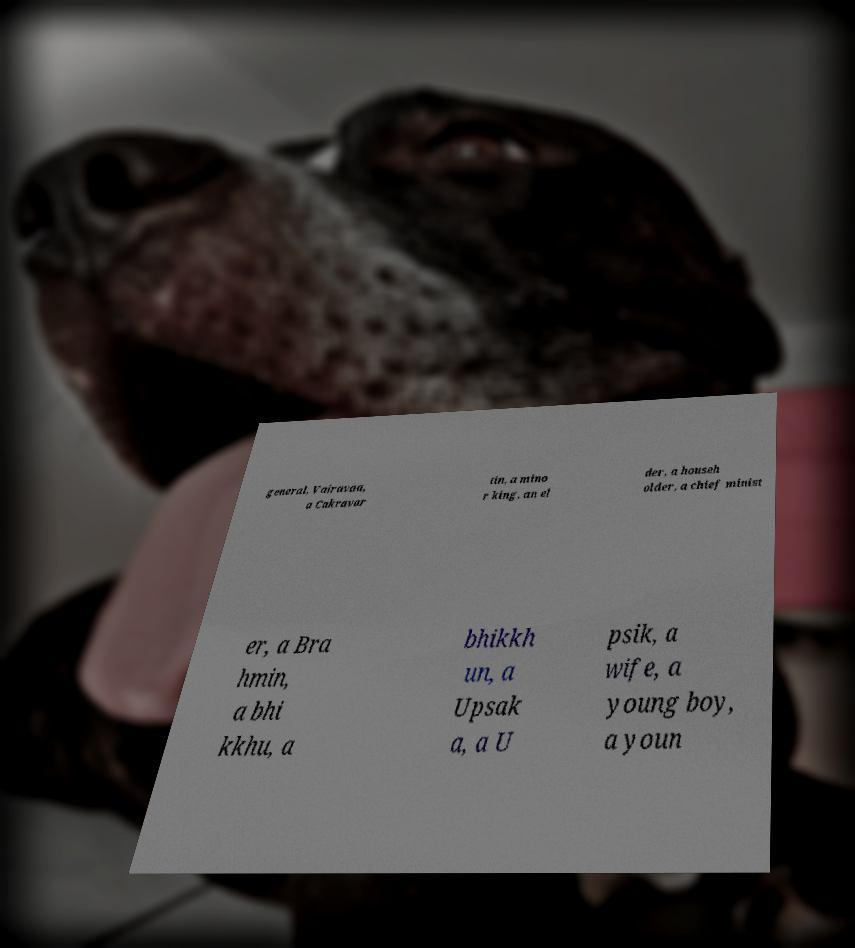For documentation purposes, I need the text within this image transcribed. Could you provide that? general, Vairavaa, a Cakravar tin, a mino r king, an el der, a househ older, a chief minist er, a Bra hmin, a bhi kkhu, a bhikkh un, a Upsak a, a U psik, a wife, a young boy, a youn 